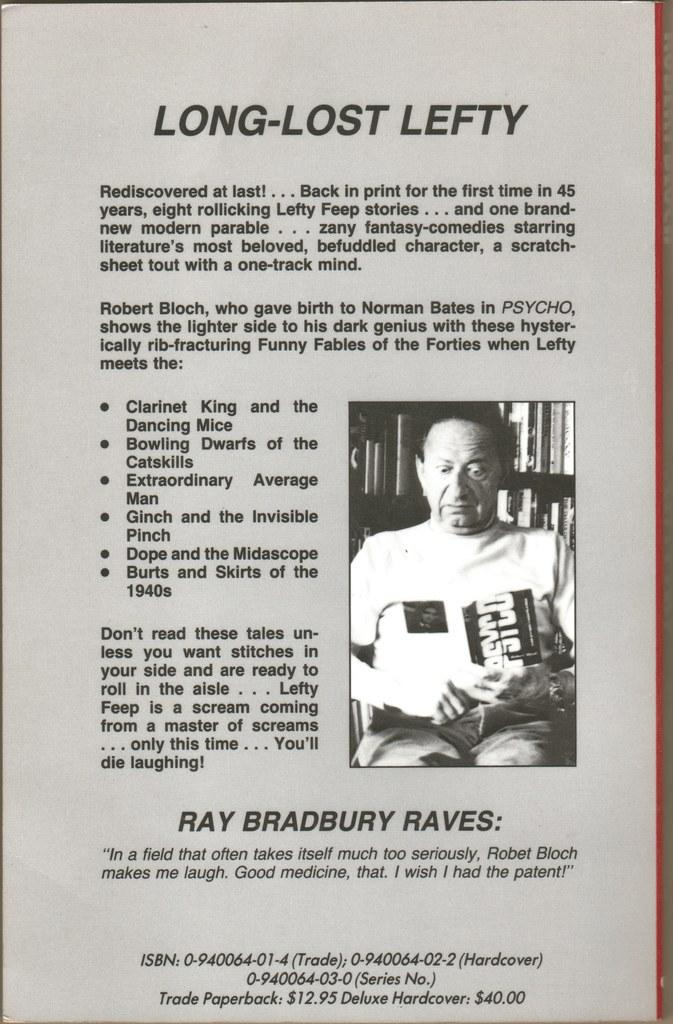What is present in the image that contains written matter? There is a photo of a man in the image. Can you describe the photo in the image? The photo in the image is of a man. What is the medium of the image? The image appears to be on a paper. How many birds are flying in the photo of the man? There are no birds present in the photo of the man; it only features a man. What is the relationship between the man in the photo and the person who took the photo? We cannot determine the relationship between the man in the photo and the person who took the photo based on the information provided. 